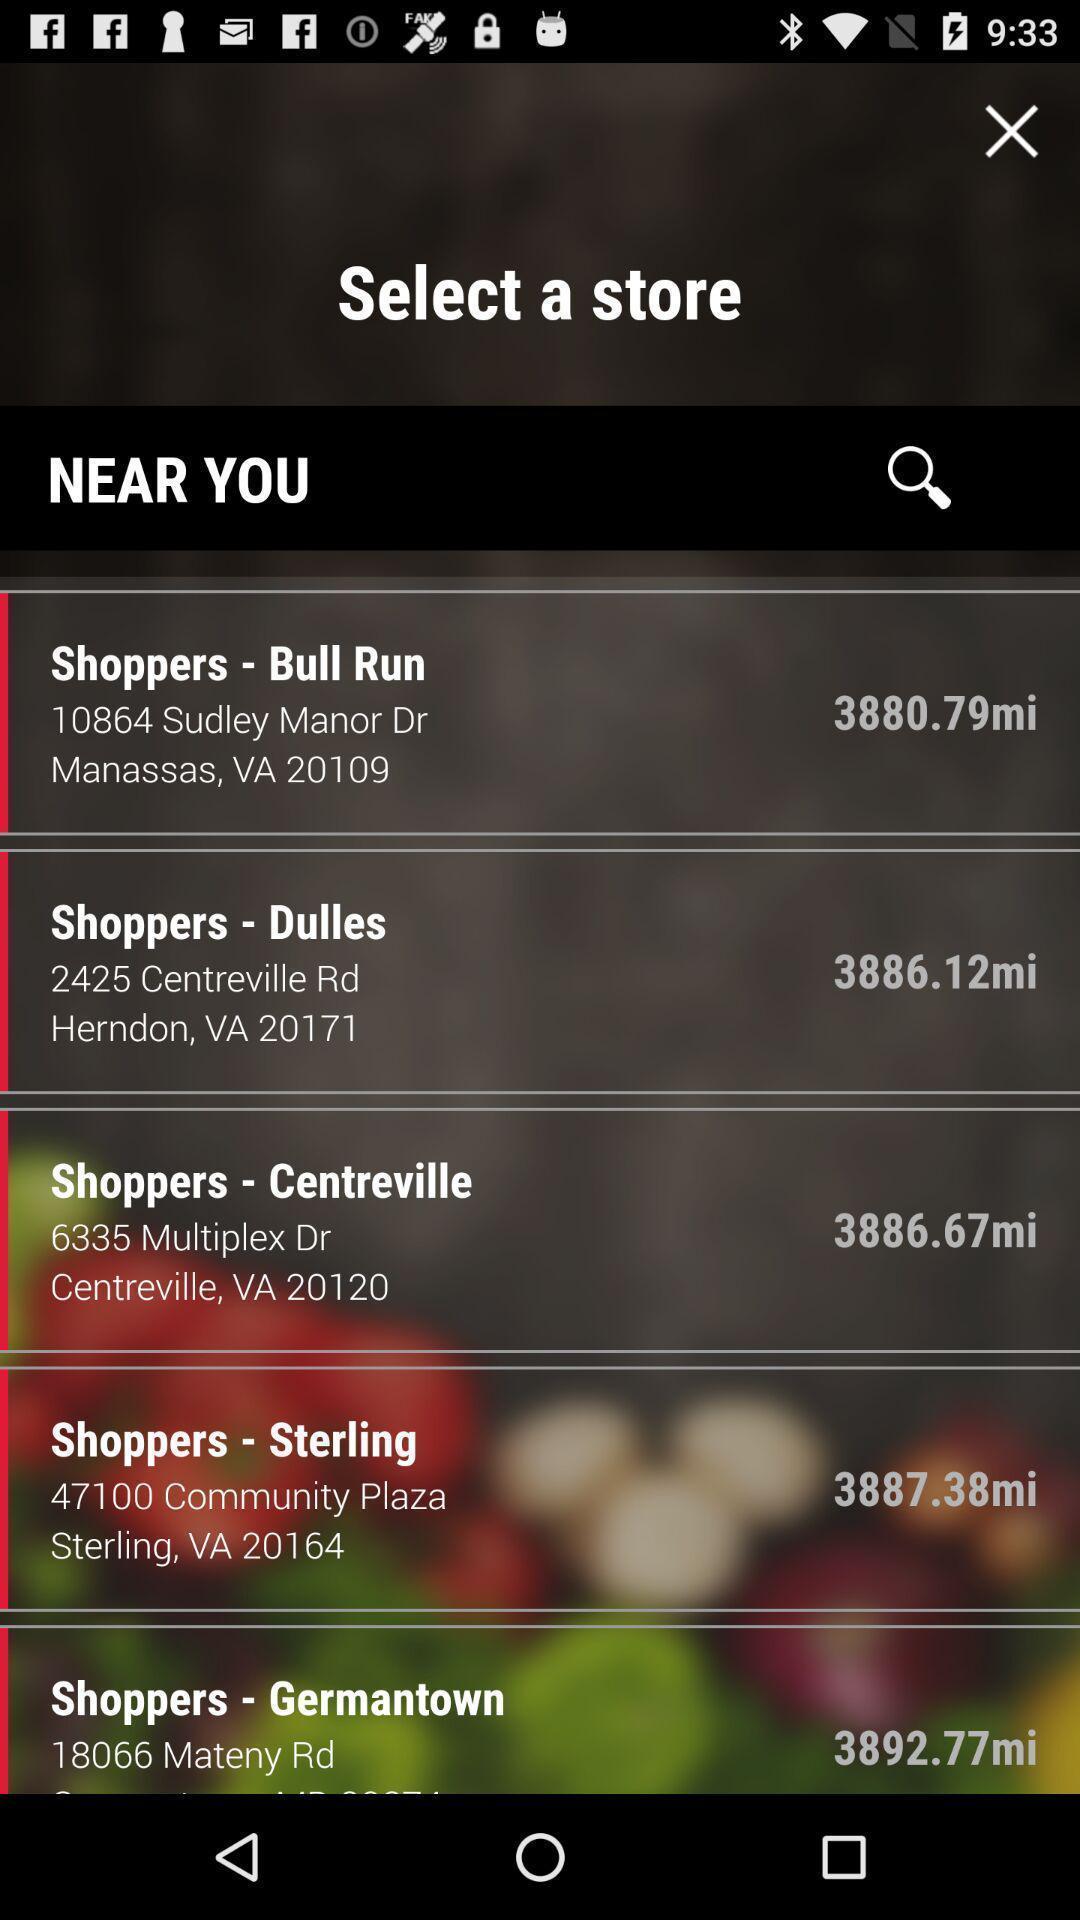Explain what's happening in this screen capture. Page showing search bar to find a store. 